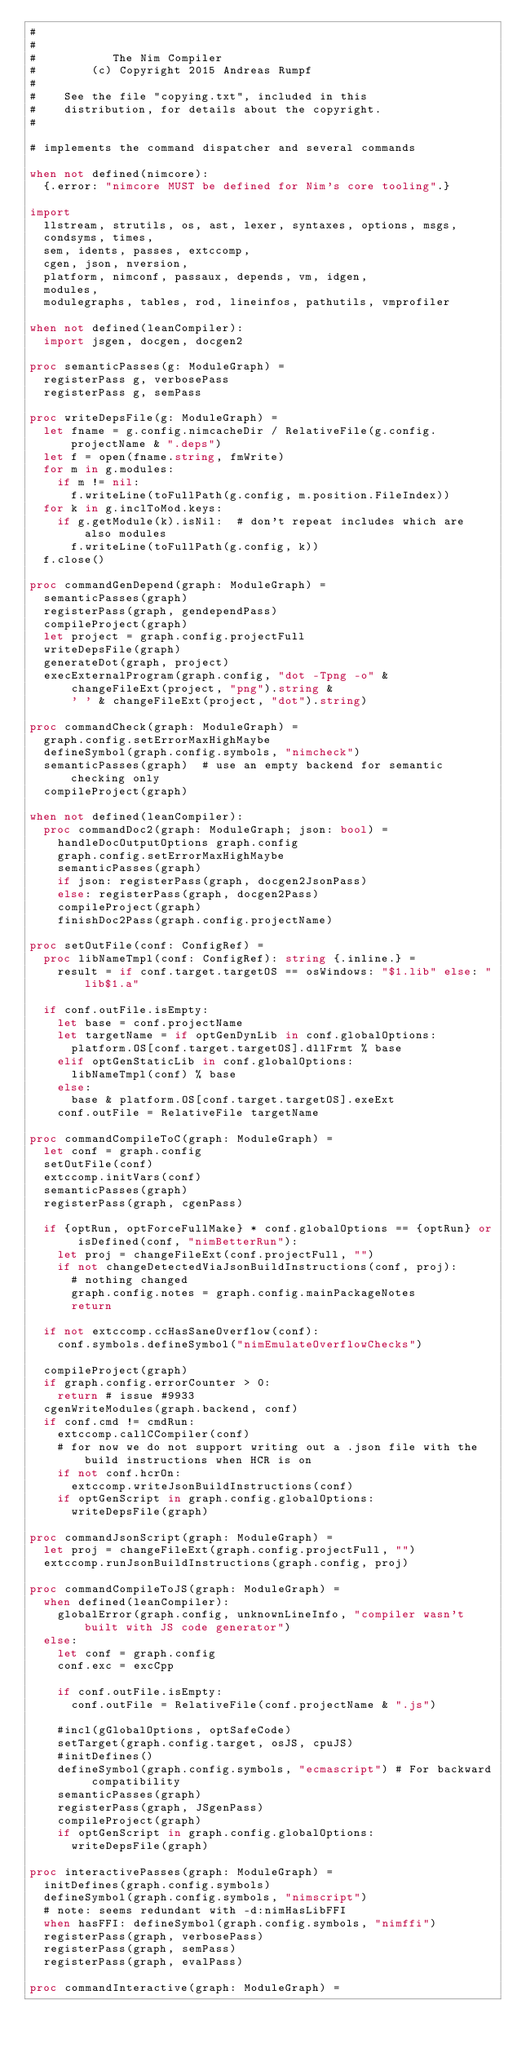<code> <loc_0><loc_0><loc_500><loc_500><_Nim_>#
#
#           The Nim Compiler
#        (c) Copyright 2015 Andreas Rumpf
#
#    See the file "copying.txt", included in this
#    distribution, for details about the copyright.
#

# implements the command dispatcher and several commands

when not defined(nimcore):
  {.error: "nimcore MUST be defined for Nim's core tooling".}

import
  llstream, strutils, os, ast, lexer, syntaxes, options, msgs,
  condsyms, times,
  sem, idents, passes, extccomp,
  cgen, json, nversion,
  platform, nimconf, passaux, depends, vm, idgen,
  modules,
  modulegraphs, tables, rod, lineinfos, pathutils, vmprofiler

when not defined(leanCompiler):
  import jsgen, docgen, docgen2

proc semanticPasses(g: ModuleGraph) =
  registerPass g, verbosePass
  registerPass g, semPass

proc writeDepsFile(g: ModuleGraph) =
  let fname = g.config.nimcacheDir / RelativeFile(g.config.projectName & ".deps")
  let f = open(fname.string, fmWrite)
  for m in g.modules:
    if m != nil:
      f.writeLine(toFullPath(g.config, m.position.FileIndex))
  for k in g.inclToMod.keys:
    if g.getModule(k).isNil:  # don't repeat includes which are also modules
      f.writeLine(toFullPath(g.config, k))
  f.close()

proc commandGenDepend(graph: ModuleGraph) =
  semanticPasses(graph)
  registerPass(graph, gendependPass)
  compileProject(graph)
  let project = graph.config.projectFull
  writeDepsFile(graph)
  generateDot(graph, project)
  execExternalProgram(graph.config, "dot -Tpng -o" &
      changeFileExt(project, "png").string &
      ' ' & changeFileExt(project, "dot").string)

proc commandCheck(graph: ModuleGraph) =
  graph.config.setErrorMaxHighMaybe
  defineSymbol(graph.config.symbols, "nimcheck")
  semanticPasses(graph)  # use an empty backend for semantic checking only
  compileProject(graph)

when not defined(leanCompiler):
  proc commandDoc2(graph: ModuleGraph; json: bool) =
    handleDocOutputOptions graph.config
    graph.config.setErrorMaxHighMaybe
    semanticPasses(graph)
    if json: registerPass(graph, docgen2JsonPass)
    else: registerPass(graph, docgen2Pass)
    compileProject(graph)
    finishDoc2Pass(graph.config.projectName)

proc setOutFile(conf: ConfigRef) =
  proc libNameTmpl(conf: ConfigRef): string {.inline.} =
    result = if conf.target.targetOS == osWindows: "$1.lib" else: "lib$1.a"

  if conf.outFile.isEmpty:
    let base = conf.projectName
    let targetName = if optGenDynLib in conf.globalOptions:
      platform.OS[conf.target.targetOS].dllFrmt % base
    elif optGenStaticLib in conf.globalOptions:
      libNameTmpl(conf) % base
    else:
      base & platform.OS[conf.target.targetOS].exeExt
    conf.outFile = RelativeFile targetName

proc commandCompileToC(graph: ModuleGraph) =
  let conf = graph.config
  setOutFile(conf)
  extccomp.initVars(conf)
  semanticPasses(graph)
  registerPass(graph, cgenPass)

  if {optRun, optForceFullMake} * conf.globalOptions == {optRun} or isDefined(conf, "nimBetterRun"):
    let proj = changeFileExt(conf.projectFull, "")
    if not changeDetectedViaJsonBuildInstructions(conf, proj):
      # nothing changed
      graph.config.notes = graph.config.mainPackageNotes
      return

  if not extccomp.ccHasSaneOverflow(conf):
    conf.symbols.defineSymbol("nimEmulateOverflowChecks")

  compileProject(graph)
  if graph.config.errorCounter > 0:
    return # issue #9933
  cgenWriteModules(graph.backend, conf)
  if conf.cmd != cmdRun:
    extccomp.callCCompiler(conf)
    # for now we do not support writing out a .json file with the build instructions when HCR is on
    if not conf.hcrOn:
      extccomp.writeJsonBuildInstructions(conf)
    if optGenScript in graph.config.globalOptions:
      writeDepsFile(graph)

proc commandJsonScript(graph: ModuleGraph) =
  let proj = changeFileExt(graph.config.projectFull, "")
  extccomp.runJsonBuildInstructions(graph.config, proj)

proc commandCompileToJS(graph: ModuleGraph) =
  when defined(leanCompiler):
    globalError(graph.config, unknownLineInfo, "compiler wasn't built with JS code generator")
  else:
    let conf = graph.config
    conf.exc = excCpp

    if conf.outFile.isEmpty:
      conf.outFile = RelativeFile(conf.projectName & ".js")

    #incl(gGlobalOptions, optSafeCode)
    setTarget(graph.config.target, osJS, cpuJS)
    #initDefines()
    defineSymbol(graph.config.symbols, "ecmascript") # For backward compatibility
    semanticPasses(graph)
    registerPass(graph, JSgenPass)
    compileProject(graph)
    if optGenScript in graph.config.globalOptions:
      writeDepsFile(graph)

proc interactivePasses(graph: ModuleGraph) =
  initDefines(graph.config.symbols)
  defineSymbol(graph.config.symbols, "nimscript")
  # note: seems redundant with -d:nimHasLibFFI
  when hasFFI: defineSymbol(graph.config.symbols, "nimffi")
  registerPass(graph, verbosePass)
  registerPass(graph, semPass)
  registerPass(graph, evalPass)

proc commandInteractive(graph: ModuleGraph) =</code> 